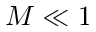Convert formula to latex. <formula><loc_0><loc_0><loc_500><loc_500>M \ll 1</formula> 